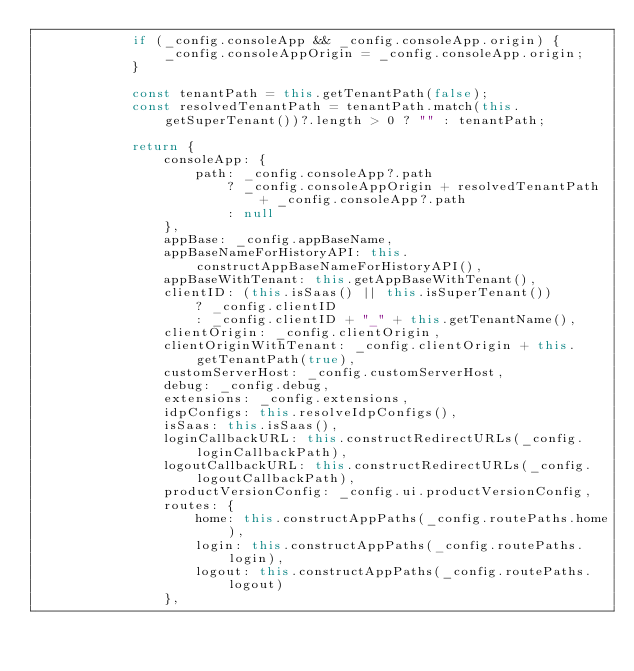Convert code to text. <code><loc_0><loc_0><loc_500><loc_500><_TypeScript_>            if (_config.consoleApp && _config.consoleApp.origin) {
                _config.consoleAppOrigin = _config.consoleApp.origin;
            }

            const tenantPath = this.getTenantPath(false);
            const resolvedTenantPath = tenantPath.match(this.getSuperTenant())?.length > 0 ? "" : tenantPath;

            return {
                consoleApp: {
                    path: _config.consoleApp?.path
                        ? _config.consoleAppOrigin + resolvedTenantPath + _config.consoleApp?.path
                        : null
                },
                appBase: _config.appBaseName,
                appBaseNameForHistoryAPI: this.constructAppBaseNameForHistoryAPI(),
                appBaseWithTenant: this.getAppBaseWithTenant(),
                clientID: (this.isSaas() || this.isSuperTenant())
                    ? _config.clientID
                    : _config.clientID + "_" + this.getTenantName(),
                clientOrigin: _config.clientOrigin,
                clientOriginWithTenant: _config.clientOrigin + this.getTenantPath(true),
                customServerHost: _config.customServerHost,
                debug: _config.debug,
                extensions: _config.extensions,
                idpConfigs: this.resolveIdpConfigs(),
                isSaas: this.isSaas(),
                loginCallbackURL: this.constructRedirectURLs(_config.loginCallbackPath),
                logoutCallbackURL: this.constructRedirectURLs(_config.logoutCallbackPath),
                productVersionConfig: _config.ui.productVersionConfig,
                routes: {
                    home: this.constructAppPaths(_config.routePaths.home),
                    login: this.constructAppPaths(_config.routePaths.login),
                    logout: this.constructAppPaths(_config.routePaths.logout)
                },</code> 